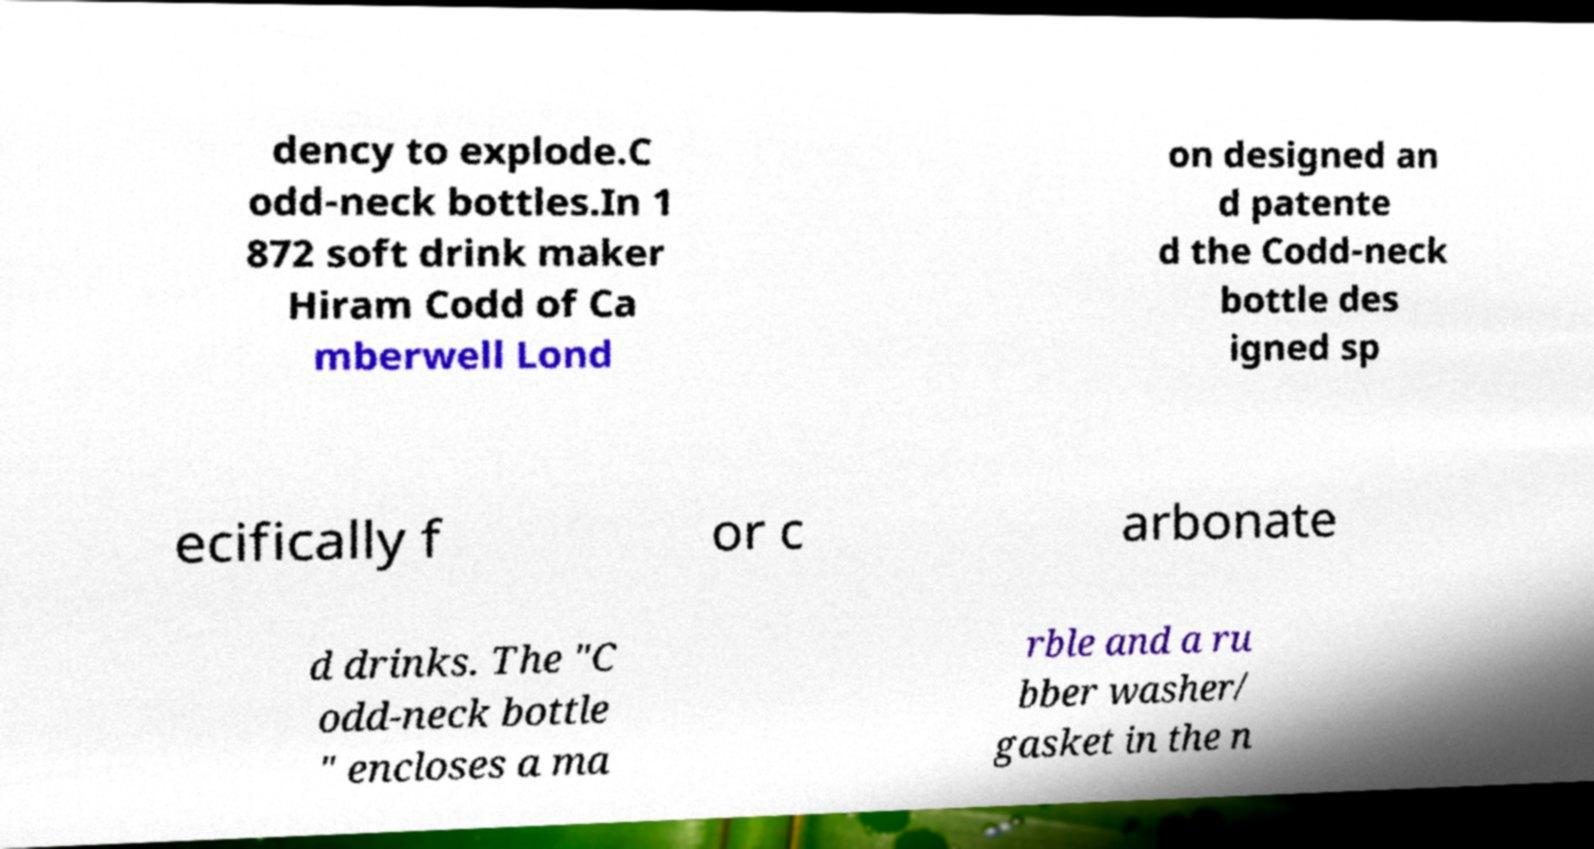There's text embedded in this image that I need extracted. Can you transcribe it verbatim? dency to explode.C odd-neck bottles.In 1 872 soft drink maker Hiram Codd of Ca mberwell Lond on designed an d patente d the Codd-neck bottle des igned sp ecifically f or c arbonate d drinks. The "C odd-neck bottle " encloses a ma rble and a ru bber washer/ gasket in the n 